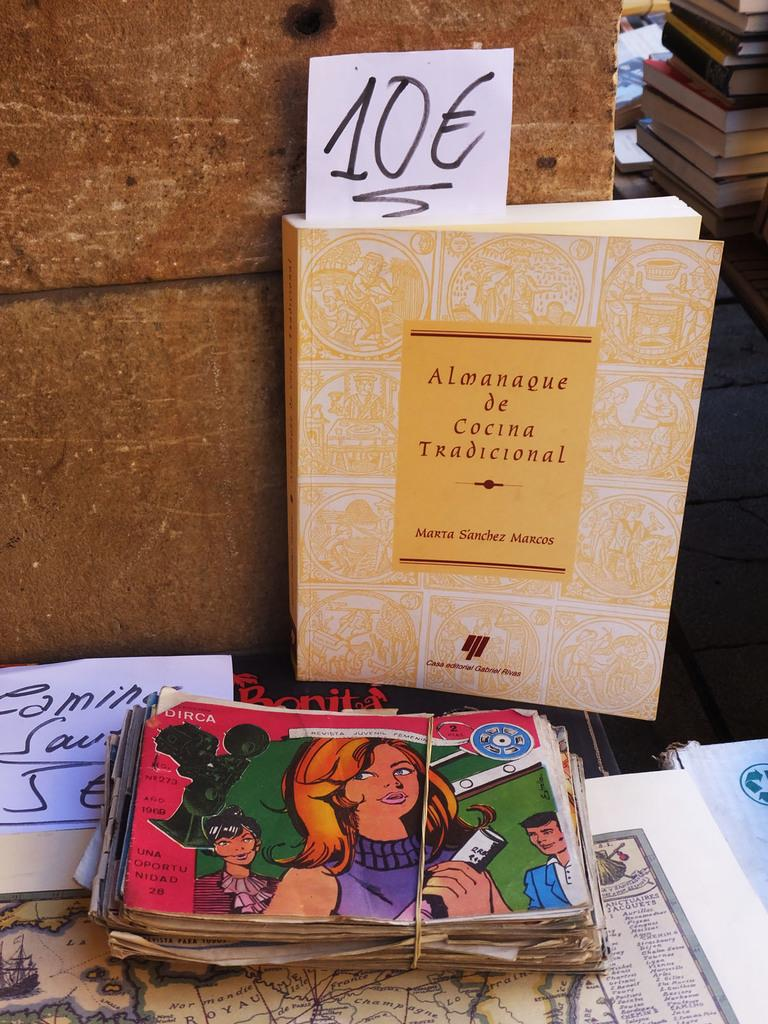<image>
Render a clear and concise summary of the photo. A book called Almanague de Cocina Tradicional resting against a wall. 